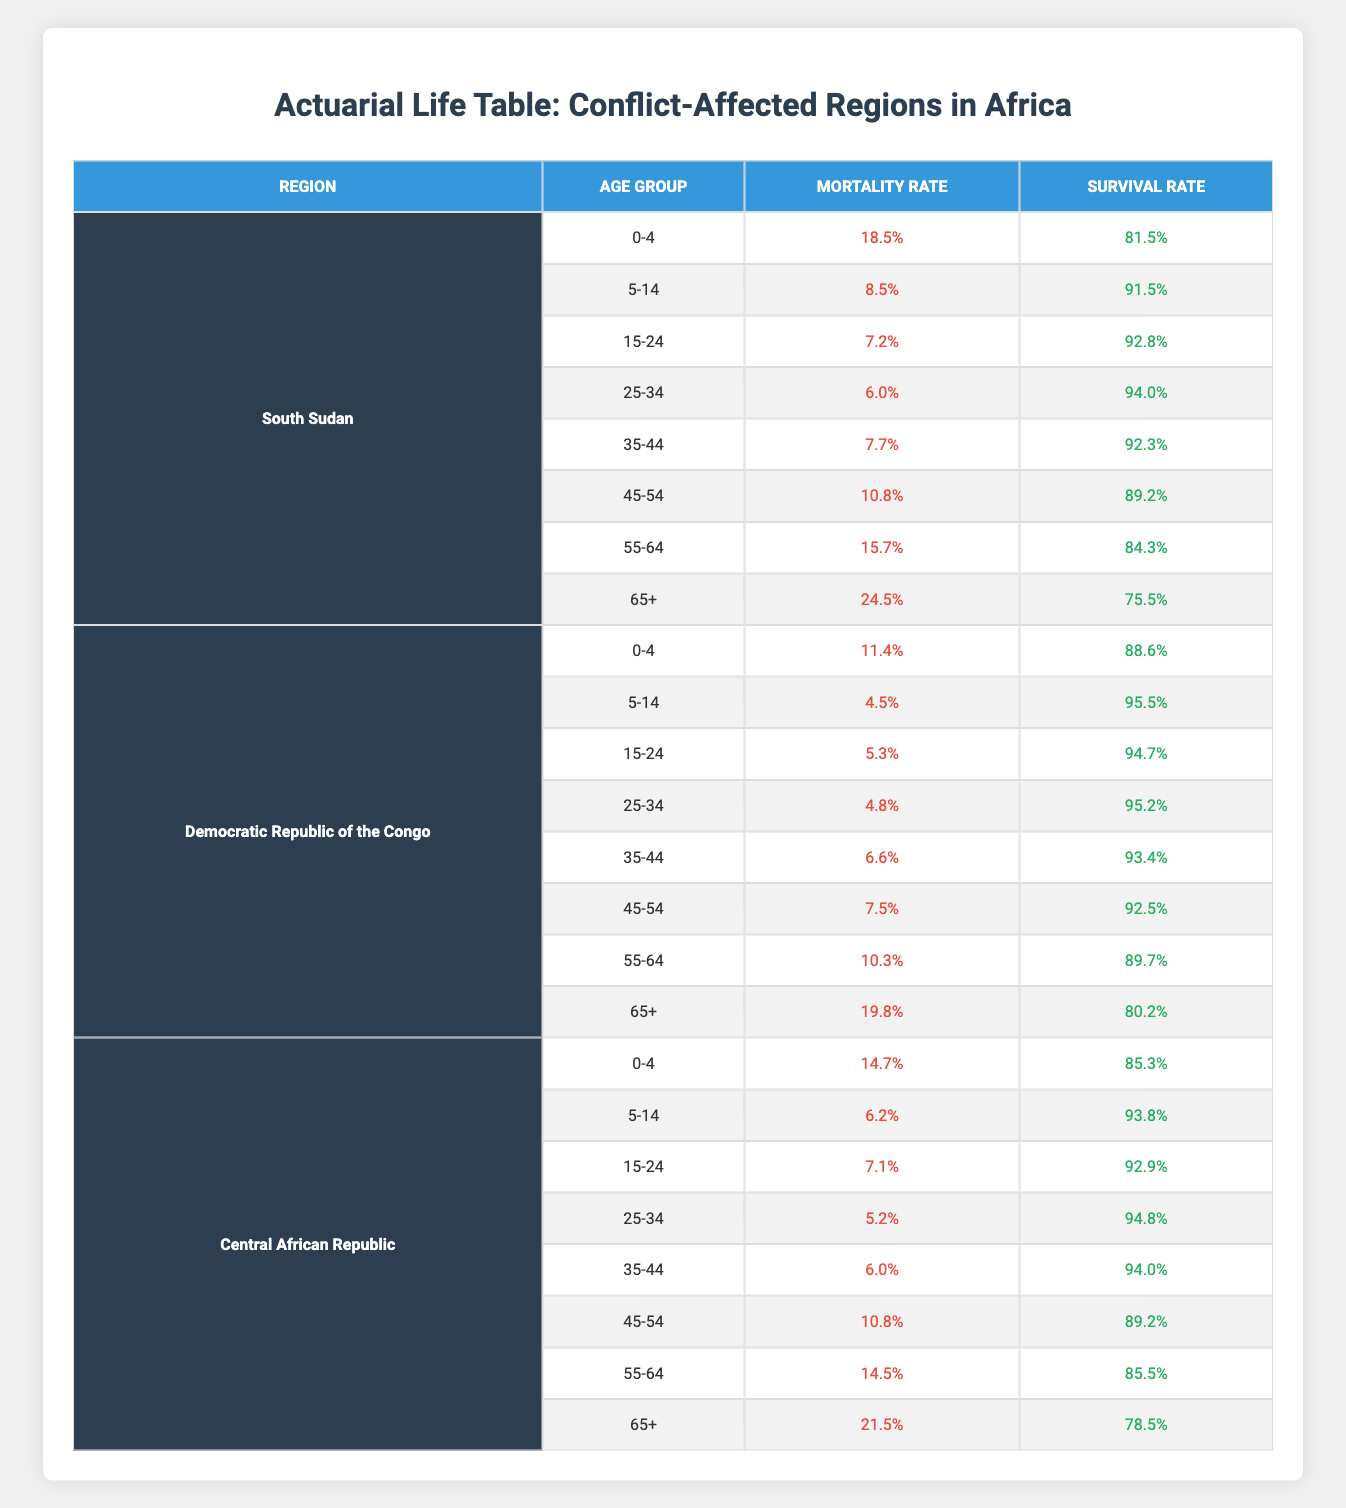What is the highest mortality rate among the age groups in South Sudan? In South Sudan, the mortality rates for each age group are as follows: 0-4 (18.5%), 5-14 (8.5%), 15-24 (7.2%), 25-34 (6.0%), 35-44 (7.7%), 45-54 (10.8%), 55-64 (15.7%), and 65+ (24.5%). The highest rate is in the age group 65+, which is 24.5%.
Answer: 24.5% Which region has the lowest survival rate for the age group 55-64? The survival rates for the age group 55-64 in the regions are as follows: South Sudan (84.3%), Democratic Republic of the Congo (89.7%), and Central African Republic (85.5%). The lowest survival rate is in South Sudan at 84.3%.
Answer: 84.3% What is the average mortality rate for the age group 0-4 across all three regions? The mortality rates for the age group 0-4 are: South Sudan (18.5%), Democratic Republic of the Congo (11.4%), and Central African Republic (14.7%). To find the average, we sum the rates (18.5 + 11.4 + 14.7 = 44.6) and divide by 3, giving us an average mortality rate of 44.6 / 3 = 14.87%.
Answer: 14.87% In which age group do we see the highest survival rate in the Democratic Republic of the Congo? Looking at the Democratic Republic of the Congo, the survival rates for each age group are: 0-4 (88.6%), 5-14 (95.5%), 15-24 (94.7%), 25-34 (95.2%), 35-44 (93.4%), 45-54 (92.5%), 55-64 (89.7%), and 65+ (80.2%). The highest survival rate is in the age group 5-14 at 95.5%.
Answer: 95.5% Is the mortality rate for ages 65+ in the Central African Republic higher than in the Democratic Republic of the Congo? The mortality rates for the age group 65+ are 21.5% in the Central African Republic and 19.8% in the Democratic Republic of the Congo. Since 21.5% is greater than 19.8%, the statement is true.
Answer: Yes 